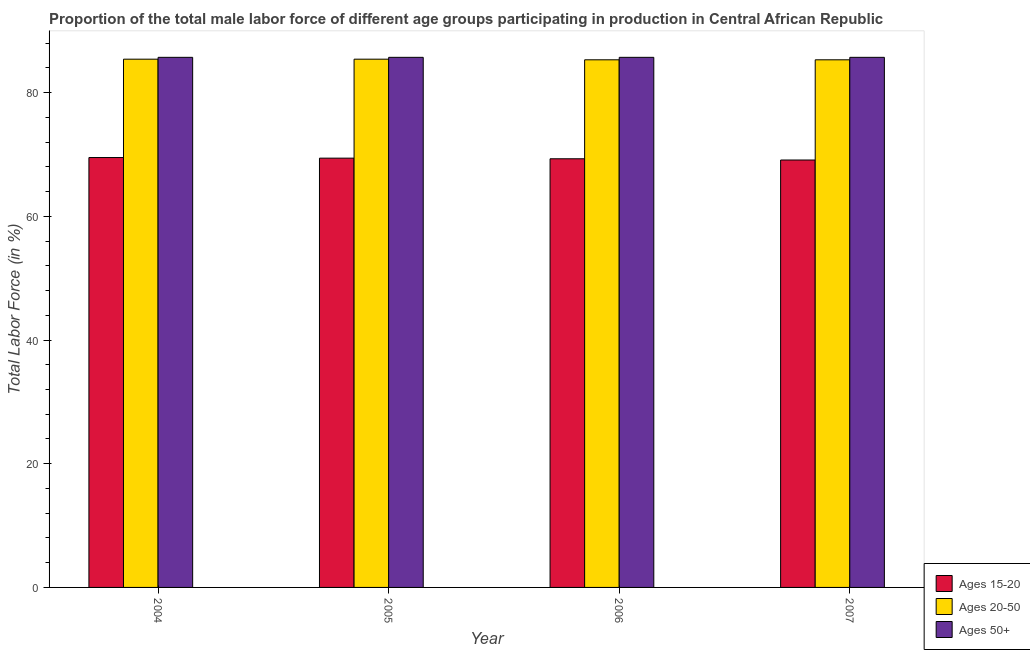How many different coloured bars are there?
Offer a terse response. 3. Are the number of bars per tick equal to the number of legend labels?
Make the answer very short. Yes. How many bars are there on the 4th tick from the left?
Make the answer very short. 3. How many bars are there on the 4th tick from the right?
Offer a very short reply. 3. What is the label of the 1st group of bars from the left?
Your answer should be compact. 2004. In how many cases, is the number of bars for a given year not equal to the number of legend labels?
Ensure brevity in your answer.  0. What is the percentage of male labor force within the age group 20-50 in 2006?
Offer a terse response. 85.3. Across all years, what is the maximum percentage of male labor force within the age group 20-50?
Keep it short and to the point. 85.4. Across all years, what is the minimum percentage of male labor force within the age group 15-20?
Ensure brevity in your answer.  69.1. In which year was the percentage of male labor force within the age group 20-50 maximum?
Your answer should be very brief. 2004. What is the total percentage of male labor force within the age group 15-20 in the graph?
Offer a terse response. 277.3. What is the difference between the percentage of male labor force within the age group 20-50 in 2004 and that in 2005?
Make the answer very short. 0. What is the difference between the percentage of male labor force within the age group 20-50 in 2006 and the percentage of male labor force within the age group 15-20 in 2005?
Offer a terse response. -0.1. What is the average percentage of male labor force above age 50 per year?
Make the answer very short. 85.7. In the year 2005, what is the difference between the percentage of male labor force above age 50 and percentage of male labor force within the age group 20-50?
Ensure brevity in your answer.  0. What is the ratio of the percentage of male labor force within the age group 15-20 in 2006 to that in 2007?
Offer a terse response. 1. Is the percentage of male labor force within the age group 15-20 in 2005 less than that in 2006?
Ensure brevity in your answer.  No. What is the difference between the highest and the lowest percentage of male labor force within the age group 20-50?
Offer a very short reply. 0.1. In how many years, is the percentage of male labor force within the age group 20-50 greater than the average percentage of male labor force within the age group 20-50 taken over all years?
Offer a terse response. 2. What does the 2nd bar from the left in 2004 represents?
Keep it short and to the point. Ages 20-50. What does the 2nd bar from the right in 2007 represents?
Offer a terse response. Ages 20-50. How many bars are there?
Your answer should be very brief. 12. Are all the bars in the graph horizontal?
Your answer should be very brief. No. How many years are there in the graph?
Your response must be concise. 4. What is the difference between two consecutive major ticks on the Y-axis?
Make the answer very short. 20. Does the graph contain any zero values?
Offer a terse response. No. Does the graph contain grids?
Provide a succinct answer. No. Where does the legend appear in the graph?
Provide a short and direct response. Bottom right. What is the title of the graph?
Offer a very short reply. Proportion of the total male labor force of different age groups participating in production in Central African Republic. What is the label or title of the X-axis?
Your answer should be compact. Year. What is the Total Labor Force (in %) of Ages 15-20 in 2004?
Your response must be concise. 69.5. What is the Total Labor Force (in %) in Ages 20-50 in 2004?
Your response must be concise. 85.4. What is the Total Labor Force (in %) of Ages 50+ in 2004?
Give a very brief answer. 85.7. What is the Total Labor Force (in %) in Ages 15-20 in 2005?
Ensure brevity in your answer.  69.4. What is the Total Labor Force (in %) in Ages 20-50 in 2005?
Give a very brief answer. 85.4. What is the Total Labor Force (in %) in Ages 50+ in 2005?
Provide a short and direct response. 85.7. What is the Total Labor Force (in %) of Ages 15-20 in 2006?
Offer a very short reply. 69.3. What is the Total Labor Force (in %) in Ages 20-50 in 2006?
Provide a succinct answer. 85.3. What is the Total Labor Force (in %) in Ages 50+ in 2006?
Offer a very short reply. 85.7. What is the Total Labor Force (in %) of Ages 15-20 in 2007?
Provide a short and direct response. 69.1. What is the Total Labor Force (in %) of Ages 20-50 in 2007?
Your answer should be compact. 85.3. What is the Total Labor Force (in %) of Ages 50+ in 2007?
Your answer should be very brief. 85.7. Across all years, what is the maximum Total Labor Force (in %) in Ages 15-20?
Keep it short and to the point. 69.5. Across all years, what is the maximum Total Labor Force (in %) of Ages 20-50?
Your response must be concise. 85.4. Across all years, what is the maximum Total Labor Force (in %) in Ages 50+?
Your answer should be compact. 85.7. Across all years, what is the minimum Total Labor Force (in %) in Ages 15-20?
Give a very brief answer. 69.1. Across all years, what is the minimum Total Labor Force (in %) of Ages 20-50?
Your response must be concise. 85.3. Across all years, what is the minimum Total Labor Force (in %) in Ages 50+?
Ensure brevity in your answer.  85.7. What is the total Total Labor Force (in %) of Ages 15-20 in the graph?
Ensure brevity in your answer.  277.3. What is the total Total Labor Force (in %) of Ages 20-50 in the graph?
Provide a succinct answer. 341.4. What is the total Total Labor Force (in %) in Ages 50+ in the graph?
Your response must be concise. 342.8. What is the difference between the Total Labor Force (in %) in Ages 15-20 in 2004 and that in 2005?
Make the answer very short. 0.1. What is the difference between the Total Labor Force (in %) of Ages 20-50 in 2004 and that in 2005?
Give a very brief answer. 0. What is the difference between the Total Labor Force (in %) of Ages 20-50 in 2004 and that in 2007?
Keep it short and to the point. 0.1. What is the difference between the Total Labor Force (in %) of Ages 50+ in 2004 and that in 2007?
Give a very brief answer. 0. What is the difference between the Total Labor Force (in %) of Ages 15-20 in 2005 and that in 2006?
Your answer should be very brief. 0.1. What is the difference between the Total Labor Force (in %) in Ages 20-50 in 2005 and that in 2006?
Ensure brevity in your answer.  0.1. What is the difference between the Total Labor Force (in %) of Ages 15-20 in 2005 and that in 2007?
Offer a very short reply. 0.3. What is the difference between the Total Labor Force (in %) of Ages 15-20 in 2006 and that in 2007?
Provide a succinct answer. 0.2. What is the difference between the Total Labor Force (in %) in Ages 20-50 in 2006 and that in 2007?
Make the answer very short. 0. What is the difference between the Total Labor Force (in %) in Ages 15-20 in 2004 and the Total Labor Force (in %) in Ages 20-50 in 2005?
Provide a succinct answer. -15.9. What is the difference between the Total Labor Force (in %) in Ages 15-20 in 2004 and the Total Labor Force (in %) in Ages 50+ in 2005?
Provide a succinct answer. -16.2. What is the difference between the Total Labor Force (in %) of Ages 15-20 in 2004 and the Total Labor Force (in %) of Ages 20-50 in 2006?
Make the answer very short. -15.8. What is the difference between the Total Labor Force (in %) in Ages 15-20 in 2004 and the Total Labor Force (in %) in Ages 50+ in 2006?
Your answer should be compact. -16.2. What is the difference between the Total Labor Force (in %) of Ages 20-50 in 2004 and the Total Labor Force (in %) of Ages 50+ in 2006?
Give a very brief answer. -0.3. What is the difference between the Total Labor Force (in %) in Ages 15-20 in 2004 and the Total Labor Force (in %) in Ages 20-50 in 2007?
Give a very brief answer. -15.8. What is the difference between the Total Labor Force (in %) in Ages 15-20 in 2004 and the Total Labor Force (in %) in Ages 50+ in 2007?
Your answer should be very brief. -16.2. What is the difference between the Total Labor Force (in %) in Ages 20-50 in 2004 and the Total Labor Force (in %) in Ages 50+ in 2007?
Make the answer very short. -0.3. What is the difference between the Total Labor Force (in %) in Ages 15-20 in 2005 and the Total Labor Force (in %) in Ages 20-50 in 2006?
Your response must be concise. -15.9. What is the difference between the Total Labor Force (in %) in Ages 15-20 in 2005 and the Total Labor Force (in %) in Ages 50+ in 2006?
Your answer should be compact. -16.3. What is the difference between the Total Labor Force (in %) in Ages 20-50 in 2005 and the Total Labor Force (in %) in Ages 50+ in 2006?
Your answer should be compact. -0.3. What is the difference between the Total Labor Force (in %) in Ages 15-20 in 2005 and the Total Labor Force (in %) in Ages 20-50 in 2007?
Make the answer very short. -15.9. What is the difference between the Total Labor Force (in %) in Ages 15-20 in 2005 and the Total Labor Force (in %) in Ages 50+ in 2007?
Your answer should be very brief. -16.3. What is the difference between the Total Labor Force (in %) of Ages 20-50 in 2005 and the Total Labor Force (in %) of Ages 50+ in 2007?
Give a very brief answer. -0.3. What is the difference between the Total Labor Force (in %) of Ages 15-20 in 2006 and the Total Labor Force (in %) of Ages 50+ in 2007?
Ensure brevity in your answer.  -16.4. What is the difference between the Total Labor Force (in %) in Ages 20-50 in 2006 and the Total Labor Force (in %) in Ages 50+ in 2007?
Offer a terse response. -0.4. What is the average Total Labor Force (in %) in Ages 15-20 per year?
Give a very brief answer. 69.33. What is the average Total Labor Force (in %) of Ages 20-50 per year?
Ensure brevity in your answer.  85.35. What is the average Total Labor Force (in %) in Ages 50+ per year?
Offer a terse response. 85.7. In the year 2004, what is the difference between the Total Labor Force (in %) of Ages 15-20 and Total Labor Force (in %) of Ages 20-50?
Ensure brevity in your answer.  -15.9. In the year 2004, what is the difference between the Total Labor Force (in %) in Ages 15-20 and Total Labor Force (in %) in Ages 50+?
Your response must be concise. -16.2. In the year 2005, what is the difference between the Total Labor Force (in %) of Ages 15-20 and Total Labor Force (in %) of Ages 20-50?
Offer a terse response. -16. In the year 2005, what is the difference between the Total Labor Force (in %) of Ages 15-20 and Total Labor Force (in %) of Ages 50+?
Ensure brevity in your answer.  -16.3. In the year 2005, what is the difference between the Total Labor Force (in %) in Ages 20-50 and Total Labor Force (in %) in Ages 50+?
Provide a succinct answer. -0.3. In the year 2006, what is the difference between the Total Labor Force (in %) in Ages 15-20 and Total Labor Force (in %) in Ages 20-50?
Offer a terse response. -16. In the year 2006, what is the difference between the Total Labor Force (in %) of Ages 15-20 and Total Labor Force (in %) of Ages 50+?
Provide a succinct answer. -16.4. In the year 2006, what is the difference between the Total Labor Force (in %) in Ages 20-50 and Total Labor Force (in %) in Ages 50+?
Offer a terse response. -0.4. In the year 2007, what is the difference between the Total Labor Force (in %) of Ages 15-20 and Total Labor Force (in %) of Ages 20-50?
Offer a very short reply. -16.2. In the year 2007, what is the difference between the Total Labor Force (in %) of Ages 15-20 and Total Labor Force (in %) of Ages 50+?
Offer a terse response. -16.6. In the year 2007, what is the difference between the Total Labor Force (in %) of Ages 20-50 and Total Labor Force (in %) of Ages 50+?
Offer a terse response. -0.4. What is the ratio of the Total Labor Force (in %) of Ages 15-20 in 2004 to that in 2005?
Your answer should be very brief. 1. What is the ratio of the Total Labor Force (in %) of Ages 20-50 in 2004 to that in 2005?
Provide a succinct answer. 1. What is the ratio of the Total Labor Force (in %) in Ages 20-50 in 2004 to that in 2006?
Keep it short and to the point. 1. What is the ratio of the Total Labor Force (in %) of Ages 50+ in 2004 to that in 2006?
Your answer should be very brief. 1. What is the ratio of the Total Labor Force (in %) of Ages 20-50 in 2005 to that in 2006?
Ensure brevity in your answer.  1. What is the ratio of the Total Labor Force (in %) of Ages 50+ in 2005 to that in 2006?
Provide a short and direct response. 1. What is the ratio of the Total Labor Force (in %) in Ages 15-20 in 2005 to that in 2007?
Your answer should be very brief. 1. What is the ratio of the Total Labor Force (in %) of Ages 20-50 in 2005 to that in 2007?
Keep it short and to the point. 1. What is the difference between the highest and the second highest Total Labor Force (in %) in Ages 50+?
Give a very brief answer. 0. What is the difference between the highest and the lowest Total Labor Force (in %) in Ages 15-20?
Your response must be concise. 0.4. What is the difference between the highest and the lowest Total Labor Force (in %) of Ages 20-50?
Ensure brevity in your answer.  0.1. 